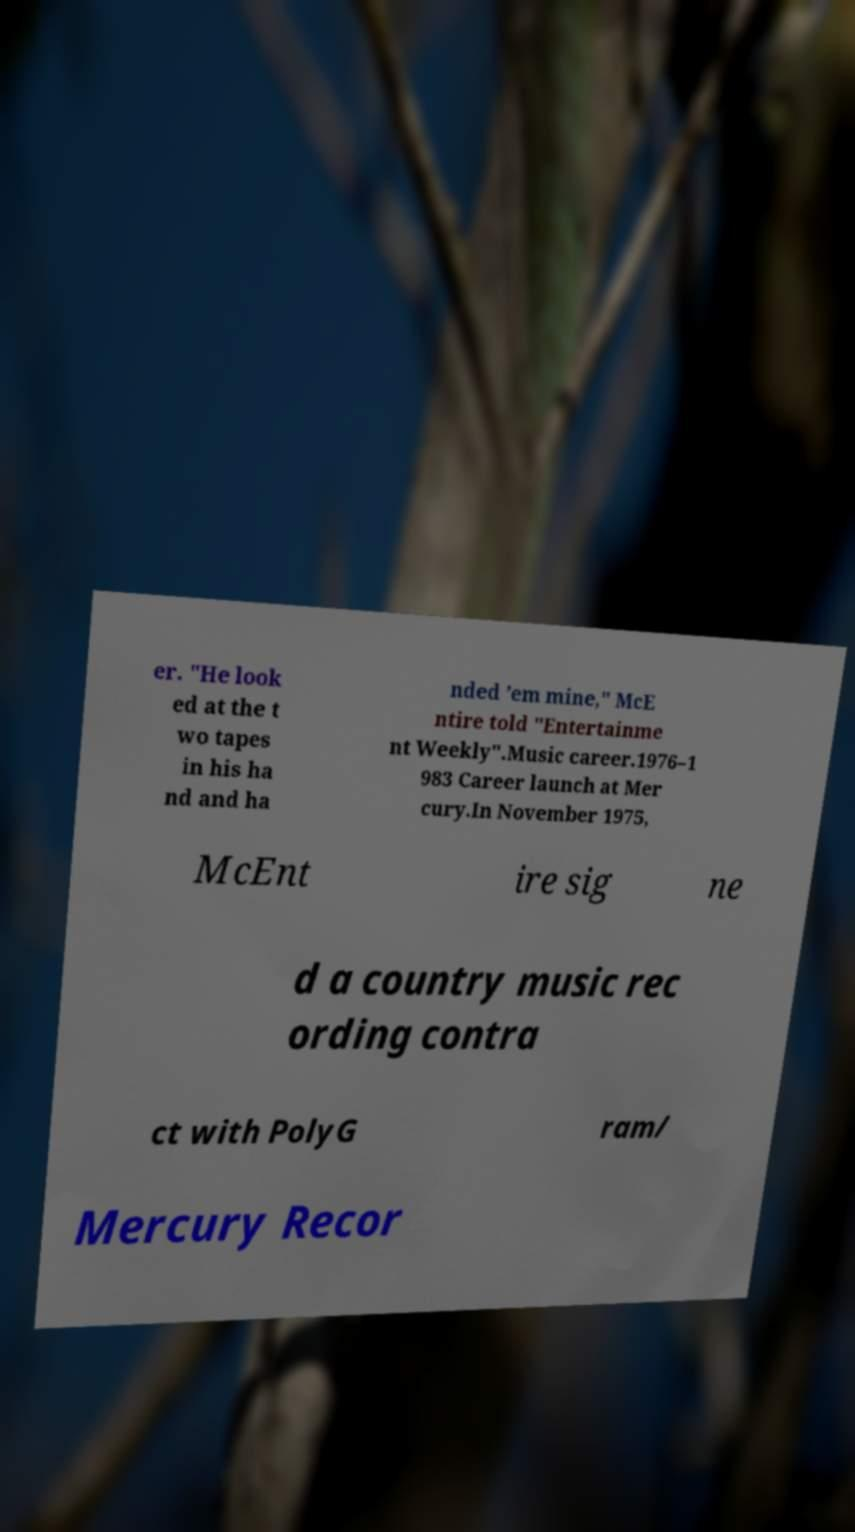Could you extract and type out the text from this image? er. "He look ed at the t wo tapes in his ha nd and ha nded ’em mine," McE ntire told "Entertainme nt Weekly".Music career.1976–1 983 Career launch at Mer cury.In November 1975, McEnt ire sig ne d a country music rec ording contra ct with PolyG ram/ Mercury Recor 